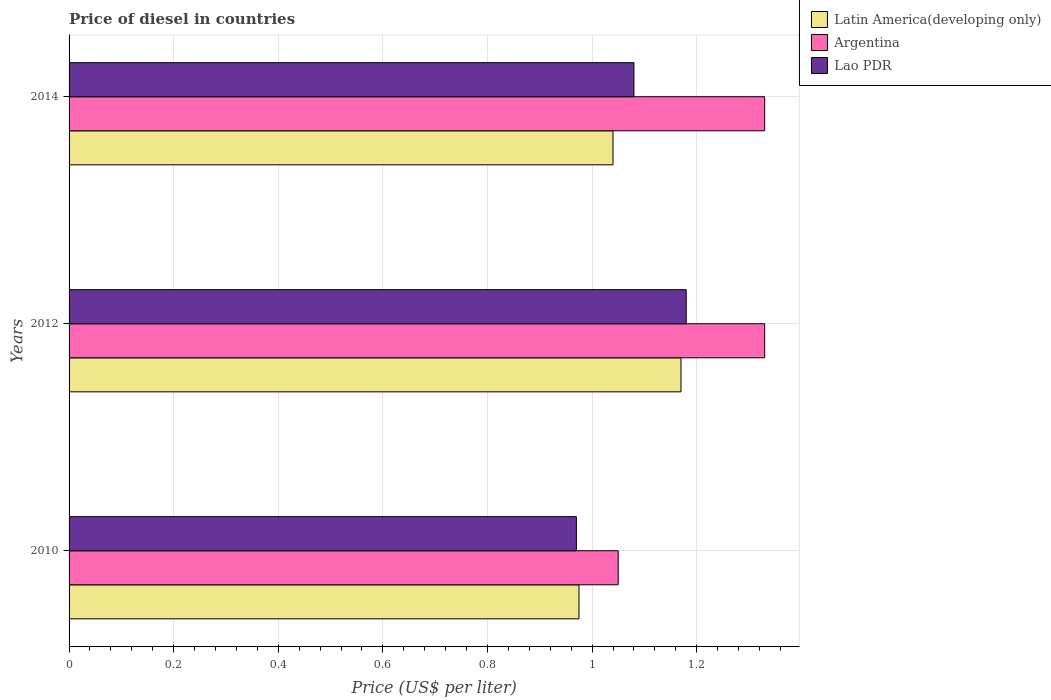How many groups of bars are there?
Offer a terse response. 3. Are the number of bars per tick equal to the number of legend labels?
Your answer should be very brief. Yes. How many bars are there on the 2nd tick from the bottom?
Offer a very short reply. 3. What is the label of the 3rd group of bars from the top?
Your response must be concise. 2010. What is the price of diesel in Argentina in 2012?
Offer a terse response. 1.33. Across all years, what is the maximum price of diesel in Latin America(developing only)?
Ensure brevity in your answer.  1.17. What is the total price of diesel in Latin America(developing only) in the graph?
Your response must be concise. 3.19. What is the difference between the price of diesel in Lao PDR in 2012 and that in 2014?
Give a very brief answer. 0.1. What is the difference between the price of diesel in Lao PDR in 2010 and the price of diesel in Latin America(developing only) in 2012?
Offer a very short reply. -0.2. What is the average price of diesel in Lao PDR per year?
Keep it short and to the point. 1.08. In the year 2014, what is the difference between the price of diesel in Lao PDR and price of diesel in Latin America(developing only)?
Offer a terse response. 0.04. In how many years, is the price of diesel in Argentina greater than 0.56 US$?
Keep it short and to the point. 3. What is the ratio of the price of diesel in Argentina in 2012 to that in 2014?
Give a very brief answer. 1. Is the price of diesel in Latin America(developing only) in 2010 less than that in 2012?
Provide a succinct answer. Yes. Is the difference between the price of diesel in Lao PDR in 2010 and 2014 greater than the difference between the price of diesel in Latin America(developing only) in 2010 and 2014?
Offer a terse response. No. What is the difference between the highest and the second highest price of diesel in Argentina?
Make the answer very short. 0. What is the difference between the highest and the lowest price of diesel in Lao PDR?
Keep it short and to the point. 0.21. In how many years, is the price of diesel in Latin America(developing only) greater than the average price of diesel in Latin America(developing only) taken over all years?
Offer a very short reply. 1. What does the 2nd bar from the top in 2010 represents?
Give a very brief answer. Argentina. Are all the bars in the graph horizontal?
Offer a terse response. Yes. How many years are there in the graph?
Provide a succinct answer. 3. What is the difference between two consecutive major ticks on the X-axis?
Provide a short and direct response. 0.2. What is the title of the graph?
Provide a succinct answer. Price of diesel in countries. What is the label or title of the X-axis?
Provide a succinct answer. Price (US$ per liter). What is the Price (US$ per liter) of Latin America(developing only) in 2010?
Your answer should be very brief. 0.97. What is the Price (US$ per liter) in Argentina in 2010?
Your answer should be compact. 1.05. What is the Price (US$ per liter) of Latin America(developing only) in 2012?
Provide a short and direct response. 1.17. What is the Price (US$ per liter) of Argentina in 2012?
Give a very brief answer. 1.33. What is the Price (US$ per liter) in Lao PDR in 2012?
Give a very brief answer. 1.18. What is the Price (US$ per liter) of Latin America(developing only) in 2014?
Keep it short and to the point. 1.04. What is the Price (US$ per liter) of Argentina in 2014?
Give a very brief answer. 1.33. What is the Price (US$ per liter) of Lao PDR in 2014?
Offer a terse response. 1.08. Across all years, what is the maximum Price (US$ per liter) of Latin America(developing only)?
Offer a very short reply. 1.17. Across all years, what is the maximum Price (US$ per liter) in Argentina?
Keep it short and to the point. 1.33. Across all years, what is the maximum Price (US$ per liter) of Lao PDR?
Give a very brief answer. 1.18. Across all years, what is the minimum Price (US$ per liter) in Latin America(developing only)?
Offer a very short reply. 0.97. Across all years, what is the minimum Price (US$ per liter) of Argentina?
Make the answer very short. 1.05. Across all years, what is the minimum Price (US$ per liter) of Lao PDR?
Keep it short and to the point. 0.97. What is the total Price (US$ per liter) in Latin America(developing only) in the graph?
Offer a terse response. 3.19. What is the total Price (US$ per liter) of Argentina in the graph?
Keep it short and to the point. 3.71. What is the total Price (US$ per liter) of Lao PDR in the graph?
Your response must be concise. 3.23. What is the difference between the Price (US$ per liter) in Latin America(developing only) in 2010 and that in 2012?
Provide a succinct answer. -0.2. What is the difference between the Price (US$ per liter) of Argentina in 2010 and that in 2012?
Offer a terse response. -0.28. What is the difference between the Price (US$ per liter) in Lao PDR in 2010 and that in 2012?
Provide a succinct answer. -0.21. What is the difference between the Price (US$ per liter) of Latin America(developing only) in 2010 and that in 2014?
Make the answer very short. -0.07. What is the difference between the Price (US$ per liter) in Argentina in 2010 and that in 2014?
Your answer should be compact. -0.28. What is the difference between the Price (US$ per liter) in Lao PDR in 2010 and that in 2014?
Offer a very short reply. -0.11. What is the difference between the Price (US$ per liter) in Latin America(developing only) in 2012 and that in 2014?
Offer a terse response. 0.13. What is the difference between the Price (US$ per liter) in Latin America(developing only) in 2010 and the Price (US$ per liter) in Argentina in 2012?
Your answer should be compact. -0.35. What is the difference between the Price (US$ per liter) in Latin America(developing only) in 2010 and the Price (US$ per liter) in Lao PDR in 2012?
Offer a very short reply. -0.2. What is the difference between the Price (US$ per liter) in Argentina in 2010 and the Price (US$ per liter) in Lao PDR in 2012?
Your answer should be compact. -0.13. What is the difference between the Price (US$ per liter) in Latin America(developing only) in 2010 and the Price (US$ per liter) in Argentina in 2014?
Keep it short and to the point. -0.35. What is the difference between the Price (US$ per liter) in Latin America(developing only) in 2010 and the Price (US$ per liter) in Lao PDR in 2014?
Ensure brevity in your answer.  -0.1. What is the difference between the Price (US$ per liter) of Argentina in 2010 and the Price (US$ per liter) of Lao PDR in 2014?
Keep it short and to the point. -0.03. What is the difference between the Price (US$ per liter) in Latin America(developing only) in 2012 and the Price (US$ per liter) in Argentina in 2014?
Make the answer very short. -0.16. What is the difference between the Price (US$ per liter) in Latin America(developing only) in 2012 and the Price (US$ per liter) in Lao PDR in 2014?
Ensure brevity in your answer.  0.09. What is the difference between the Price (US$ per liter) in Argentina in 2012 and the Price (US$ per liter) in Lao PDR in 2014?
Provide a short and direct response. 0.25. What is the average Price (US$ per liter) of Latin America(developing only) per year?
Your answer should be very brief. 1.06. What is the average Price (US$ per liter) of Argentina per year?
Provide a succinct answer. 1.24. What is the average Price (US$ per liter) of Lao PDR per year?
Your response must be concise. 1.08. In the year 2010, what is the difference between the Price (US$ per liter) in Latin America(developing only) and Price (US$ per liter) in Argentina?
Your answer should be compact. -0.07. In the year 2010, what is the difference between the Price (US$ per liter) in Latin America(developing only) and Price (US$ per liter) in Lao PDR?
Your answer should be compact. 0.01. In the year 2010, what is the difference between the Price (US$ per liter) of Argentina and Price (US$ per liter) of Lao PDR?
Your answer should be very brief. 0.08. In the year 2012, what is the difference between the Price (US$ per liter) in Latin America(developing only) and Price (US$ per liter) in Argentina?
Your answer should be compact. -0.16. In the year 2012, what is the difference between the Price (US$ per liter) of Latin America(developing only) and Price (US$ per liter) of Lao PDR?
Keep it short and to the point. -0.01. In the year 2014, what is the difference between the Price (US$ per liter) in Latin America(developing only) and Price (US$ per liter) in Argentina?
Your response must be concise. -0.29. In the year 2014, what is the difference between the Price (US$ per liter) of Latin America(developing only) and Price (US$ per liter) of Lao PDR?
Your response must be concise. -0.04. What is the ratio of the Price (US$ per liter) of Latin America(developing only) in 2010 to that in 2012?
Your response must be concise. 0.83. What is the ratio of the Price (US$ per liter) of Argentina in 2010 to that in 2012?
Provide a short and direct response. 0.79. What is the ratio of the Price (US$ per liter) of Lao PDR in 2010 to that in 2012?
Ensure brevity in your answer.  0.82. What is the ratio of the Price (US$ per liter) in Latin America(developing only) in 2010 to that in 2014?
Offer a very short reply. 0.94. What is the ratio of the Price (US$ per liter) in Argentina in 2010 to that in 2014?
Ensure brevity in your answer.  0.79. What is the ratio of the Price (US$ per liter) of Lao PDR in 2010 to that in 2014?
Offer a very short reply. 0.9. What is the ratio of the Price (US$ per liter) in Argentina in 2012 to that in 2014?
Make the answer very short. 1. What is the ratio of the Price (US$ per liter) of Lao PDR in 2012 to that in 2014?
Give a very brief answer. 1.09. What is the difference between the highest and the second highest Price (US$ per liter) of Latin America(developing only)?
Ensure brevity in your answer.  0.13. What is the difference between the highest and the second highest Price (US$ per liter) of Argentina?
Offer a terse response. 0. What is the difference between the highest and the second highest Price (US$ per liter) in Lao PDR?
Your response must be concise. 0.1. What is the difference between the highest and the lowest Price (US$ per liter) of Latin America(developing only)?
Give a very brief answer. 0.2. What is the difference between the highest and the lowest Price (US$ per liter) in Argentina?
Your answer should be compact. 0.28. What is the difference between the highest and the lowest Price (US$ per liter) of Lao PDR?
Keep it short and to the point. 0.21. 